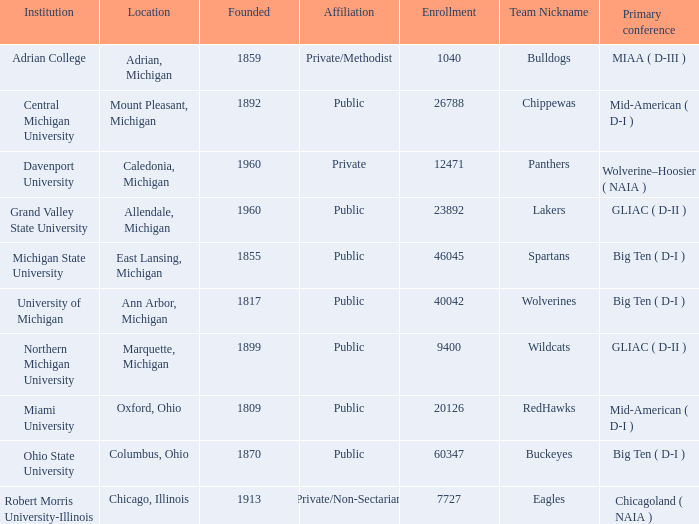What is the registration for the redhawks? 1.0. 